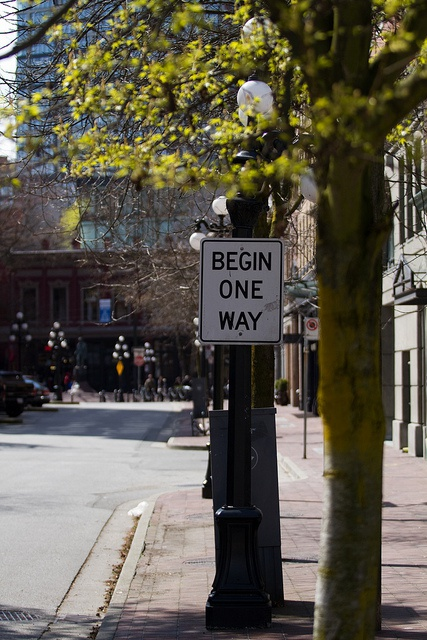Describe the objects in this image and their specific colors. I can see car in white, black, and gray tones, car in white, black, gray, darkgreen, and darkgray tones, people in white, black, and gray tones, people in white, black, and gray tones, and car in white, black, and gray tones in this image. 